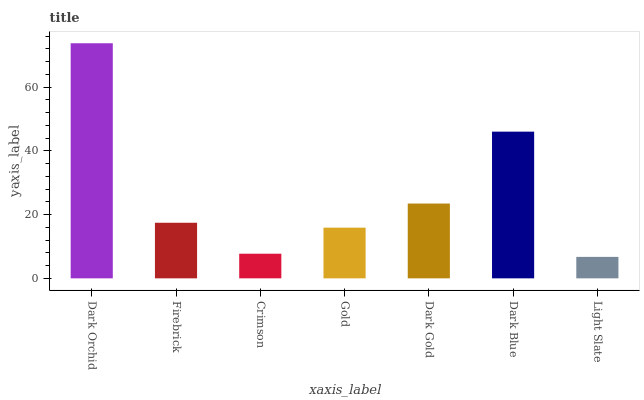Is Light Slate the minimum?
Answer yes or no. Yes. Is Dark Orchid the maximum?
Answer yes or no. Yes. Is Firebrick the minimum?
Answer yes or no. No. Is Firebrick the maximum?
Answer yes or no. No. Is Dark Orchid greater than Firebrick?
Answer yes or no. Yes. Is Firebrick less than Dark Orchid?
Answer yes or no. Yes. Is Firebrick greater than Dark Orchid?
Answer yes or no. No. Is Dark Orchid less than Firebrick?
Answer yes or no. No. Is Firebrick the high median?
Answer yes or no. Yes. Is Firebrick the low median?
Answer yes or no. Yes. Is Crimson the high median?
Answer yes or no. No. Is Light Slate the low median?
Answer yes or no. No. 